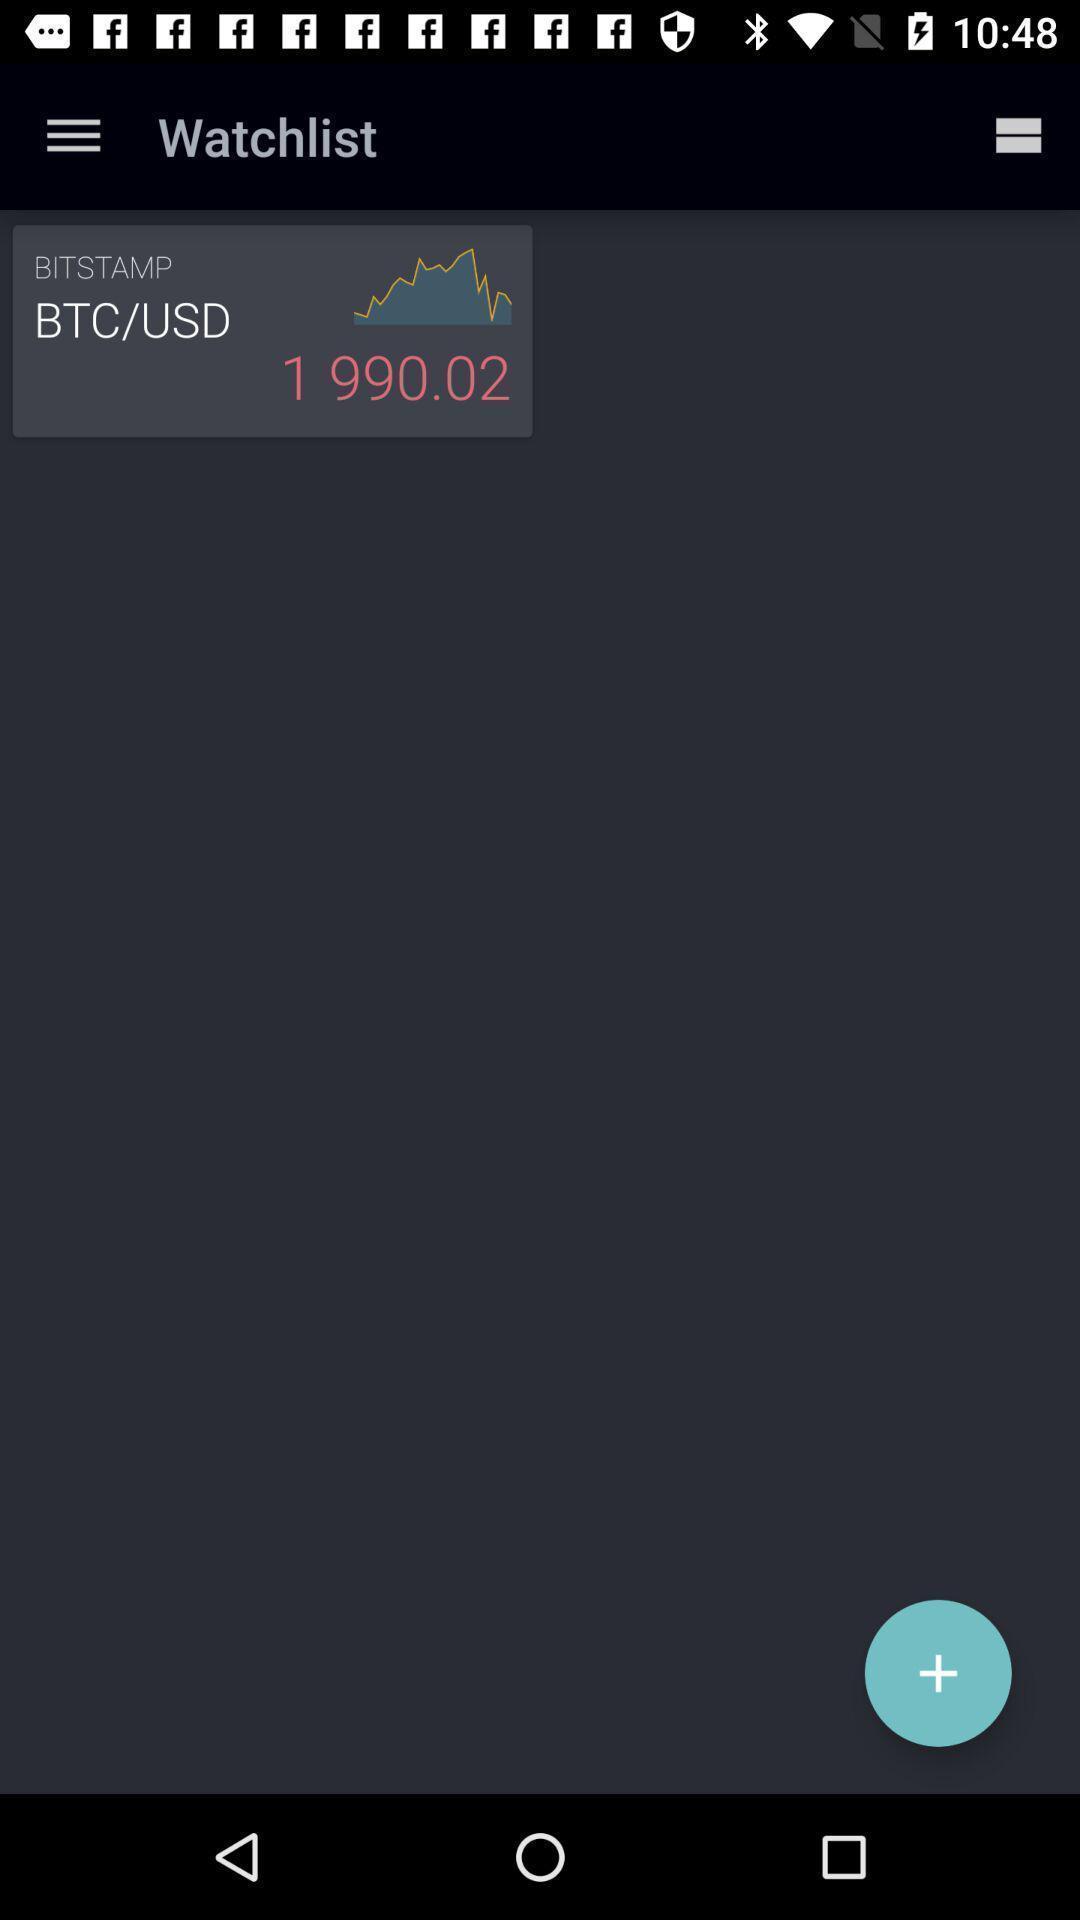Explain the elements present in this screenshot. Trading app displayed watchlist to be added. 